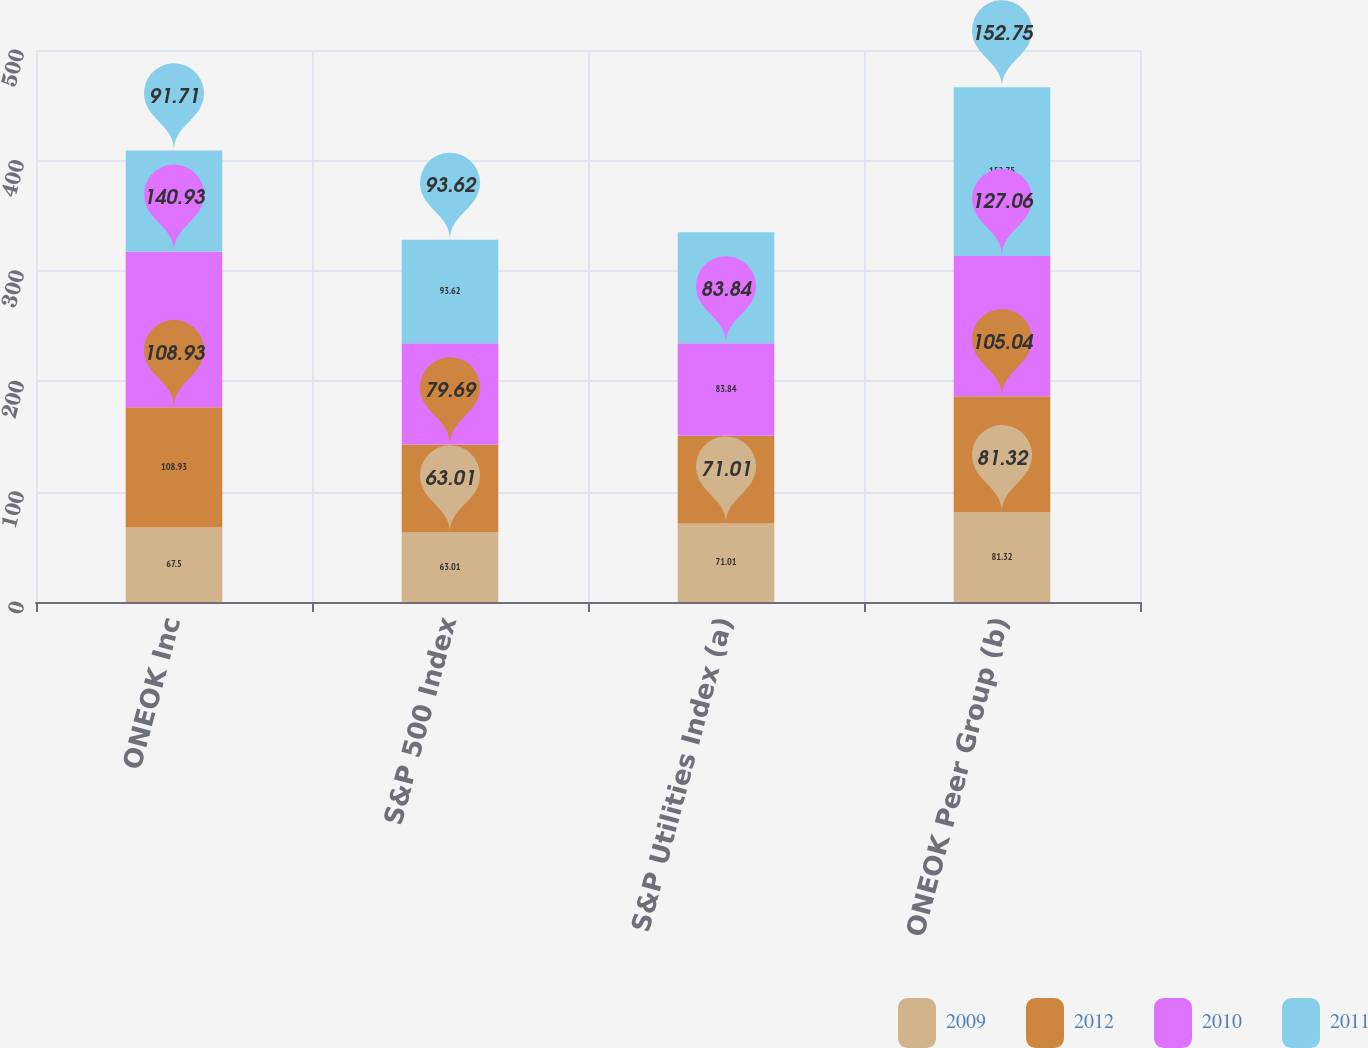Convert chart. <chart><loc_0><loc_0><loc_500><loc_500><stacked_bar_chart><ecel><fcel>ONEOK Inc<fcel>S&P 500 Index<fcel>S&P Utilities Index (a)<fcel>ONEOK Peer Group (b)<nl><fcel>2009<fcel>67.5<fcel>63.01<fcel>71.01<fcel>81.32<nl><fcel>2012<fcel>108.93<fcel>79.69<fcel>79.48<fcel>105.04<nl><fcel>2010<fcel>140.93<fcel>91.71<fcel>83.84<fcel>127.06<nl><fcel>2011<fcel>91.71<fcel>93.62<fcel>100.57<fcel>152.75<nl></chart> 